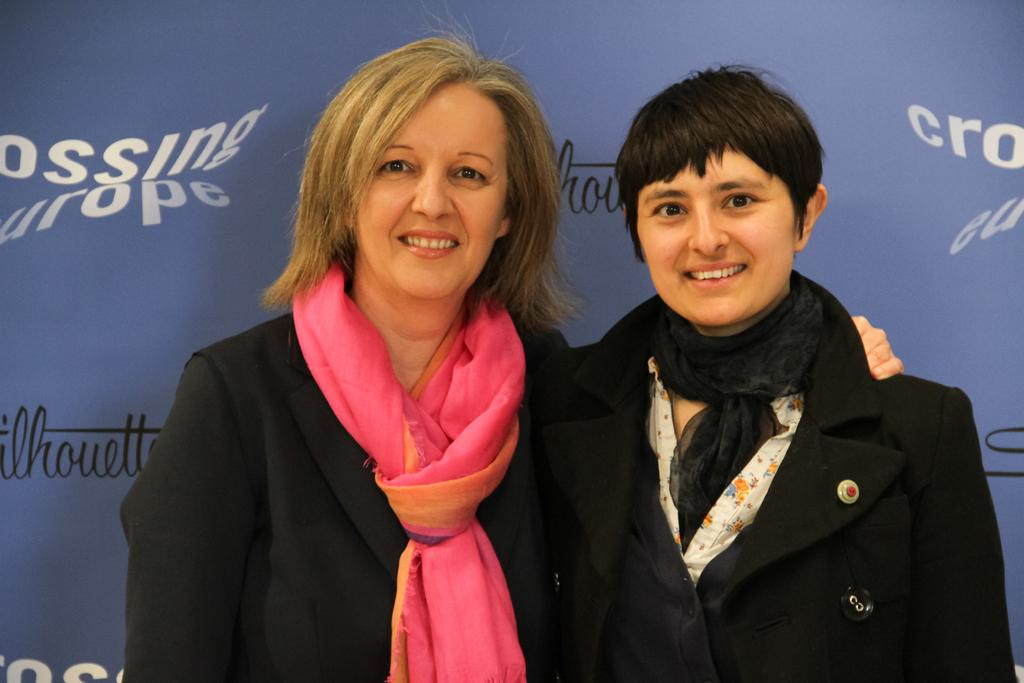How many people are in the image? There are two ladies in the center of the image. What can be seen in the background of the image? There is a poster in the background of the image. What type of ant can be seen leading the ladies in the image? There are no ants present in the image, and the ladies are not being led by any creature. 